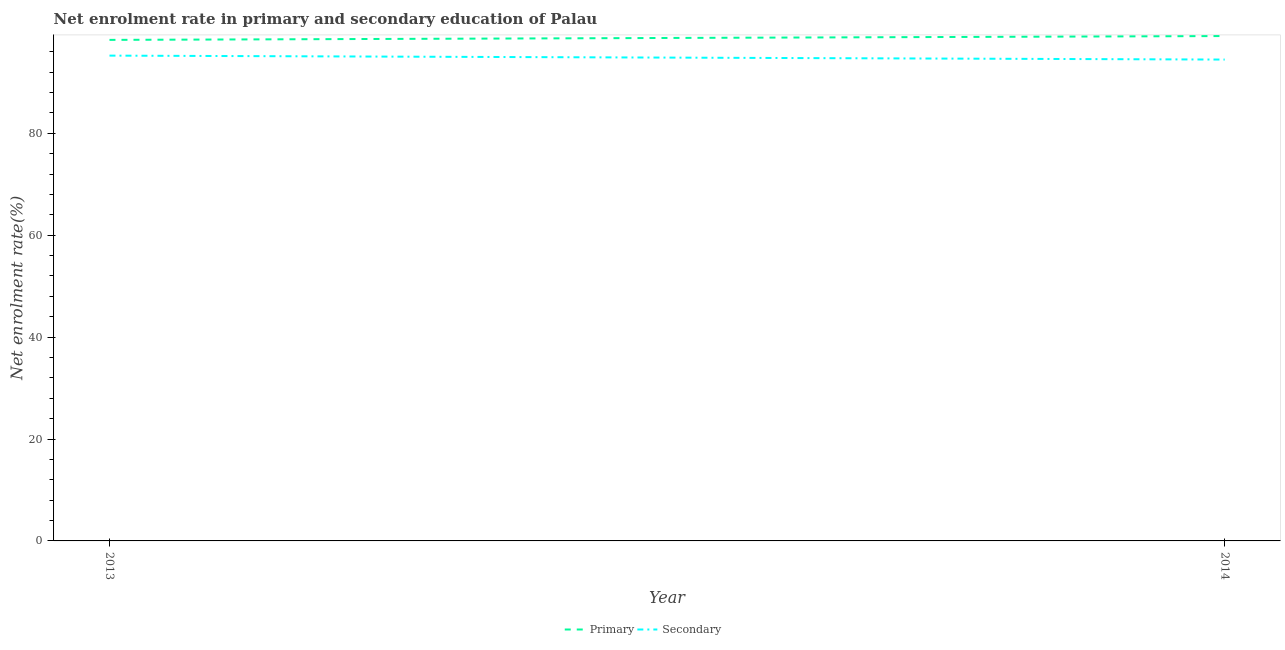How many different coloured lines are there?
Ensure brevity in your answer.  2. Does the line corresponding to enrollment rate in secondary education intersect with the line corresponding to enrollment rate in primary education?
Ensure brevity in your answer.  No. What is the enrollment rate in primary education in 2013?
Your response must be concise. 98.34. Across all years, what is the maximum enrollment rate in primary education?
Offer a very short reply. 99.09. Across all years, what is the minimum enrollment rate in secondary education?
Your answer should be very brief. 94.48. In which year was the enrollment rate in primary education maximum?
Make the answer very short. 2014. What is the total enrollment rate in secondary education in the graph?
Your response must be concise. 189.73. What is the difference between the enrollment rate in primary education in 2013 and that in 2014?
Make the answer very short. -0.75. What is the difference between the enrollment rate in primary education in 2013 and the enrollment rate in secondary education in 2014?
Your answer should be very brief. 3.86. What is the average enrollment rate in primary education per year?
Provide a short and direct response. 98.72. In the year 2014, what is the difference between the enrollment rate in primary education and enrollment rate in secondary education?
Provide a short and direct response. 4.62. In how many years, is the enrollment rate in secondary education greater than 80 %?
Your answer should be very brief. 2. What is the ratio of the enrollment rate in primary education in 2013 to that in 2014?
Your answer should be very brief. 0.99. In how many years, is the enrollment rate in secondary education greater than the average enrollment rate in secondary education taken over all years?
Make the answer very short. 1. How many lines are there?
Offer a terse response. 2. How many years are there in the graph?
Provide a succinct answer. 2. What is the difference between two consecutive major ticks on the Y-axis?
Ensure brevity in your answer.  20. Are the values on the major ticks of Y-axis written in scientific E-notation?
Offer a terse response. No. Does the graph contain any zero values?
Offer a very short reply. No. Does the graph contain grids?
Give a very brief answer. No. Where does the legend appear in the graph?
Provide a succinct answer. Bottom center. How many legend labels are there?
Your response must be concise. 2. What is the title of the graph?
Keep it short and to the point. Net enrolment rate in primary and secondary education of Palau. Does "Revenue" appear as one of the legend labels in the graph?
Keep it short and to the point. No. What is the label or title of the Y-axis?
Provide a succinct answer. Net enrolment rate(%). What is the Net enrolment rate(%) in Primary in 2013?
Your answer should be compact. 98.34. What is the Net enrolment rate(%) of Secondary in 2013?
Provide a succinct answer. 95.25. What is the Net enrolment rate(%) of Primary in 2014?
Offer a very short reply. 99.09. What is the Net enrolment rate(%) of Secondary in 2014?
Offer a terse response. 94.48. Across all years, what is the maximum Net enrolment rate(%) of Primary?
Offer a terse response. 99.09. Across all years, what is the maximum Net enrolment rate(%) in Secondary?
Your response must be concise. 95.25. Across all years, what is the minimum Net enrolment rate(%) of Primary?
Give a very brief answer. 98.34. Across all years, what is the minimum Net enrolment rate(%) of Secondary?
Provide a short and direct response. 94.48. What is the total Net enrolment rate(%) in Primary in the graph?
Keep it short and to the point. 197.43. What is the total Net enrolment rate(%) of Secondary in the graph?
Your answer should be compact. 189.73. What is the difference between the Net enrolment rate(%) of Primary in 2013 and that in 2014?
Ensure brevity in your answer.  -0.75. What is the difference between the Net enrolment rate(%) of Secondary in 2013 and that in 2014?
Provide a succinct answer. 0.78. What is the difference between the Net enrolment rate(%) of Primary in 2013 and the Net enrolment rate(%) of Secondary in 2014?
Give a very brief answer. 3.86. What is the average Net enrolment rate(%) of Primary per year?
Your response must be concise. 98.72. What is the average Net enrolment rate(%) of Secondary per year?
Your answer should be very brief. 94.86. In the year 2013, what is the difference between the Net enrolment rate(%) in Primary and Net enrolment rate(%) in Secondary?
Ensure brevity in your answer.  3.09. In the year 2014, what is the difference between the Net enrolment rate(%) in Primary and Net enrolment rate(%) in Secondary?
Provide a succinct answer. 4.62. What is the ratio of the Net enrolment rate(%) in Primary in 2013 to that in 2014?
Your answer should be very brief. 0.99. What is the ratio of the Net enrolment rate(%) of Secondary in 2013 to that in 2014?
Provide a succinct answer. 1.01. What is the difference between the highest and the second highest Net enrolment rate(%) of Primary?
Provide a succinct answer. 0.75. What is the difference between the highest and the second highest Net enrolment rate(%) in Secondary?
Offer a very short reply. 0.78. What is the difference between the highest and the lowest Net enrolment rate(%) in Primary?
Your answer should be compact. 0.75. What is the difference between the highest and the lowest Net enrolment rate(%) of Secondary?
Your response must be concise. 0.78. 